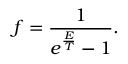<formula> <loc_0><loc_0><loc_500><loc_500>f = \frac { 1 } { e ^ { \frac { E } { T } } - 1 } .</formula> 